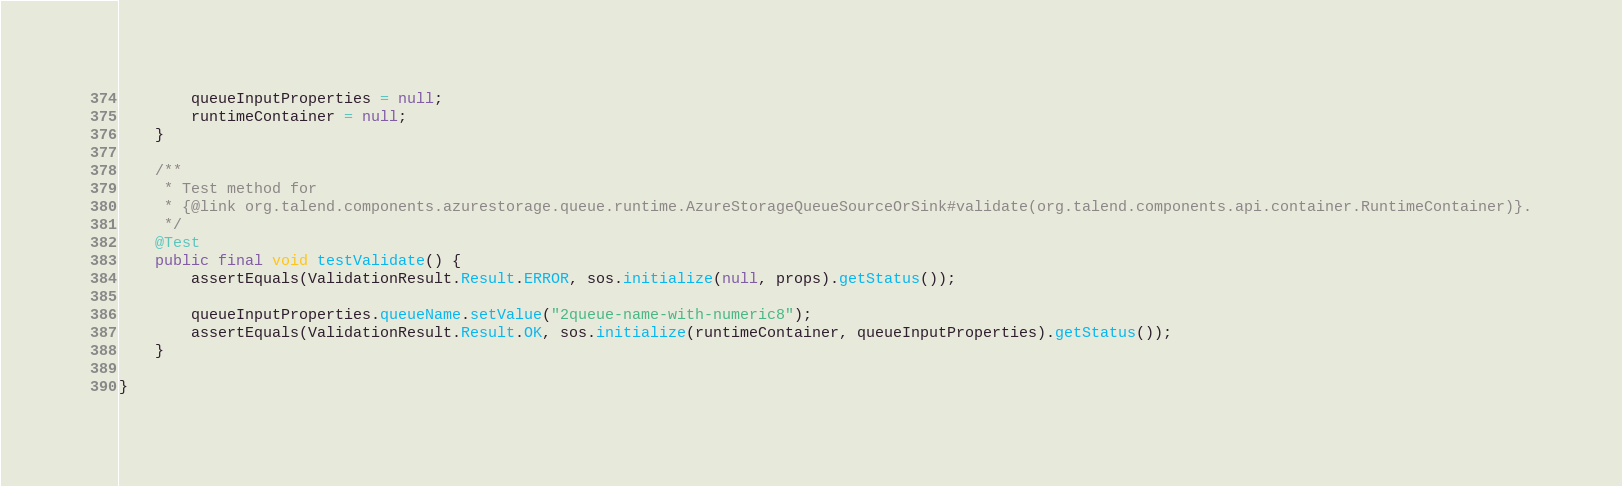<code> <loc_0><loc_0><loc_500><loc_500><_Java_>        queueInputProperties = null;
        runtimeContainer = null;
    }

    /**
     * Test method for
     * {@link org.talend.components.azurestorage.queue.runtime.AzureStorageQueueSourceOrSink#validate(org.talend.components.api.container.RuntimeContainer)}.
     */
    @Test
    public final void testValidate() {
        assertEquals(ValidationResult.Result.ERROR, sos.initialize(null, props).getStatus());

        queueInputProperties.queueName.setValue("2queue-name-with-numeric8");
        assertEquals(ValidationResult.Result.OK, sos.initialize(runtimeContainer, queueInputProperties).getStatus());
    }

}
</code> 